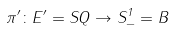<formula> <loc_0><loc_0><loc_500><loc_500>\pi ^ { \prime } \colon E ^ { \prime } = S Q \to S ^ { 1 } _ { - } = B</formula> 